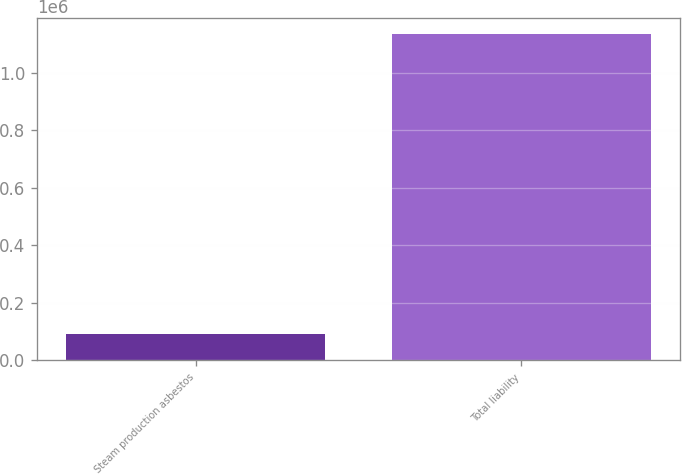Convert chart. <chart><loc_0><loc_0><loc_500><loc_500><bar_chart><fcel>Steam production asbestos<fcel>Total liability<nl><fcel>93141<fcel>1.13518e+06<nl></chart> 